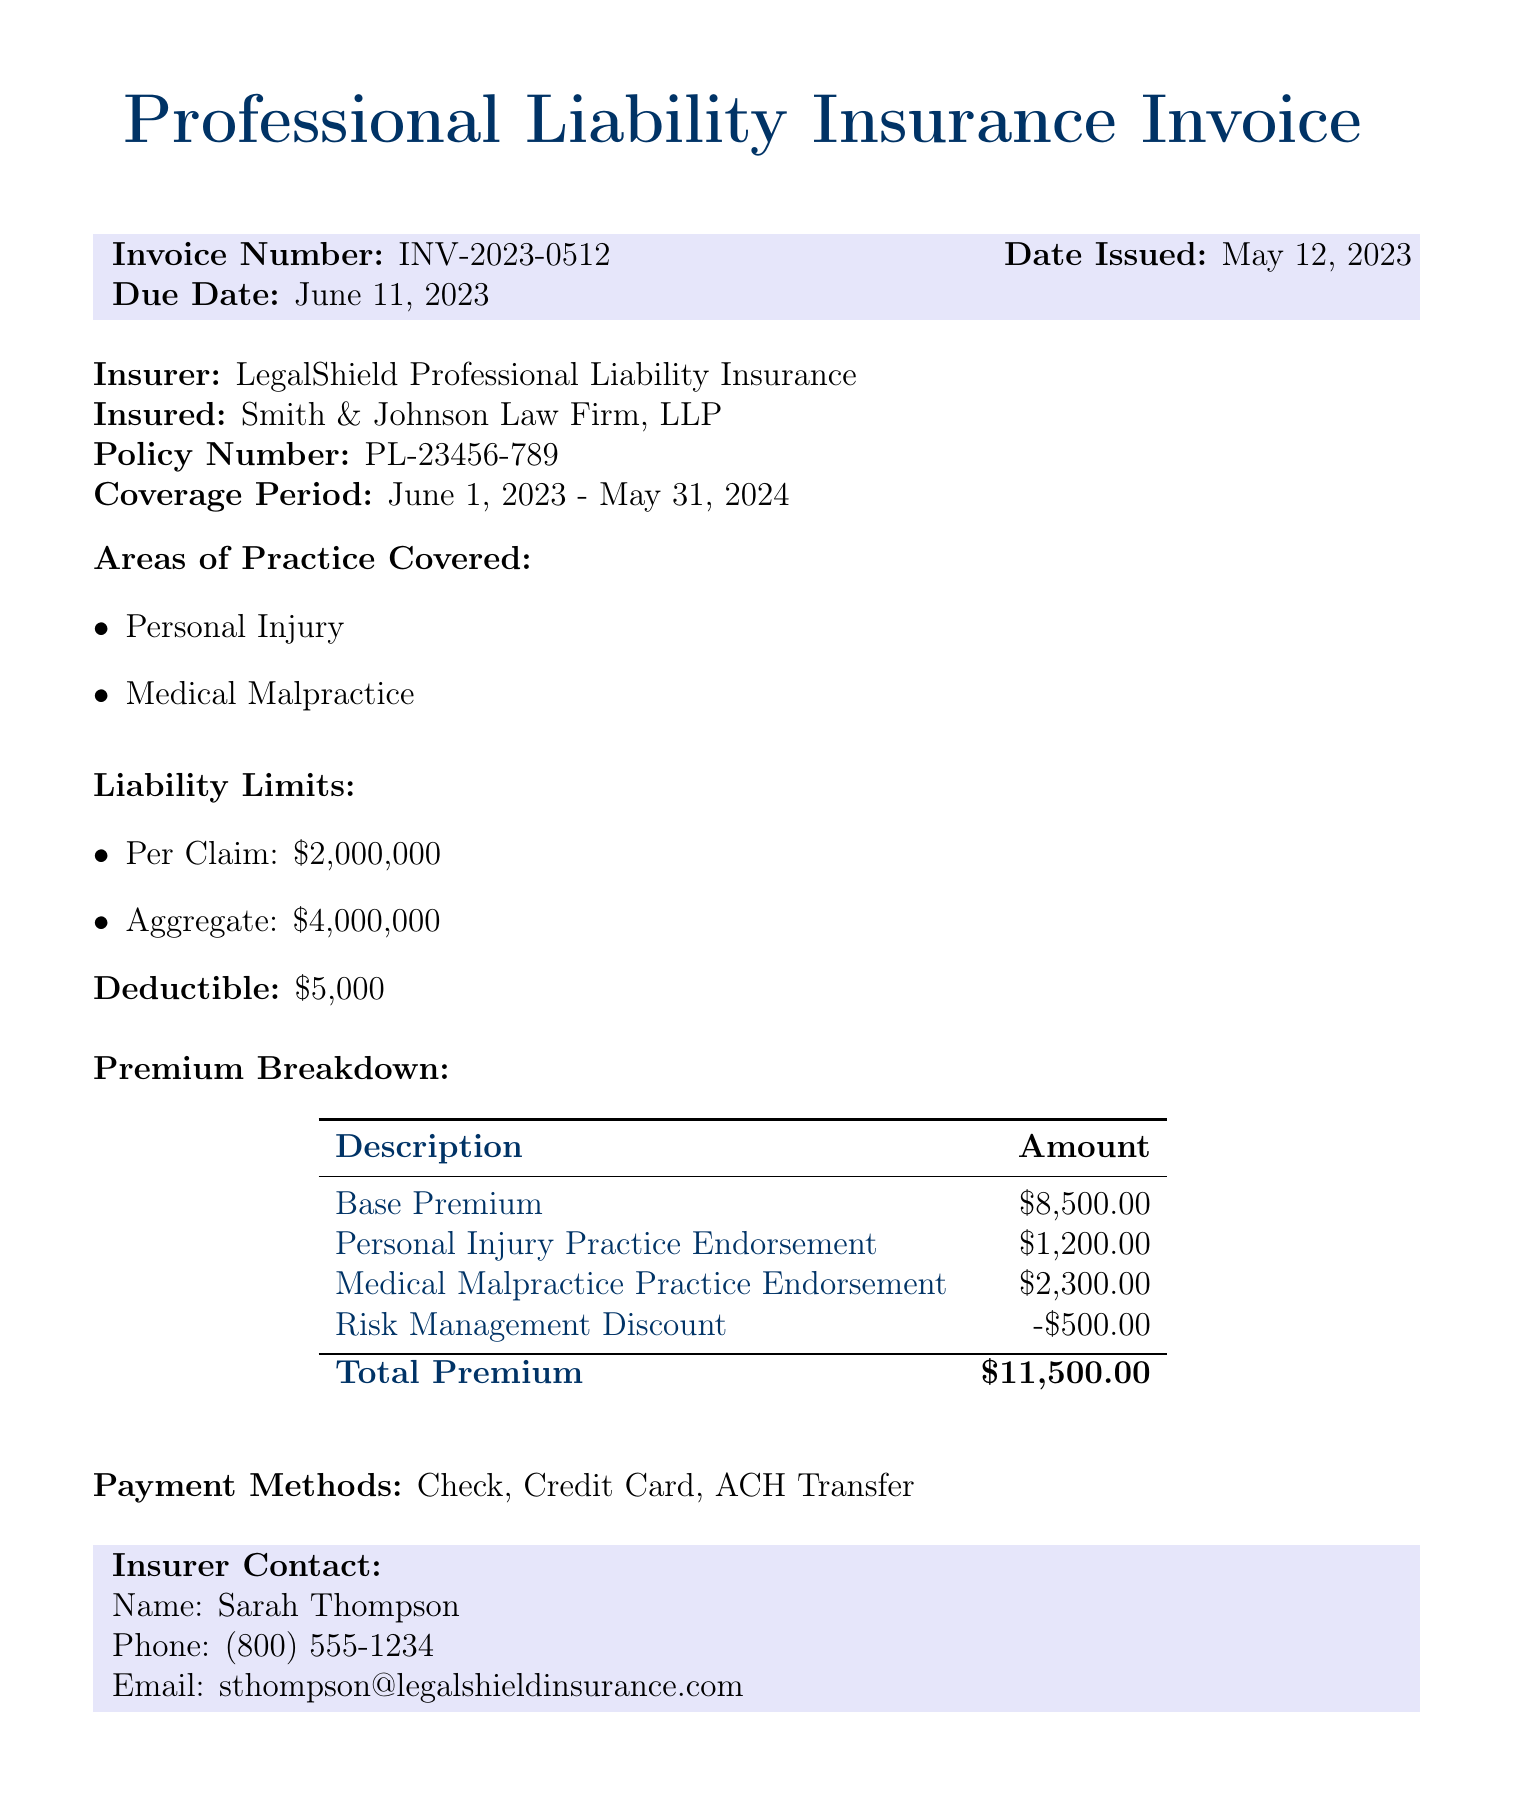What is the invoice number? The invoice number is stated prominently in the document for easy reference.
Answer: INV-2023-0512 What is the total premium amount? The total premium amount is the sum of individual premium components listed in the breakdown.
Answer: $11,500.00 Who is the insured party? The insured party is indicated in the document to clarify who holds the insurance.
Answer: Smith & Johnson Law Firm, LLP What is the coverage period? The coverage period is specified to indicate the duration of the insurance policy.
Answer: June 1, 2023 - May 31, 2024 What is the deductible amount? The deductible amount is mentioned to inform the insured about their out-of-pocket costs before the insurance coverage applies.
Answer: $5,000 How much is the Personal Injury Practice Endorsement? This reflects an additional cost specific to the area of personal injury within the premium breakdown.
Answer: $1,200.00 What is the name of the insurer contact? The insurer contact provides a point of communication for any queries related to the policy.
Answer: Sarah Thompson What is the phone number of the insurer contact? The phone number allows for direct communication with the insurer for assistance.
Answer: (800) 555-1234 How much is the risk management discount? This figure represents the reduction applied to the total premium amount as a discount for risk management.
Answer: -$500.00 